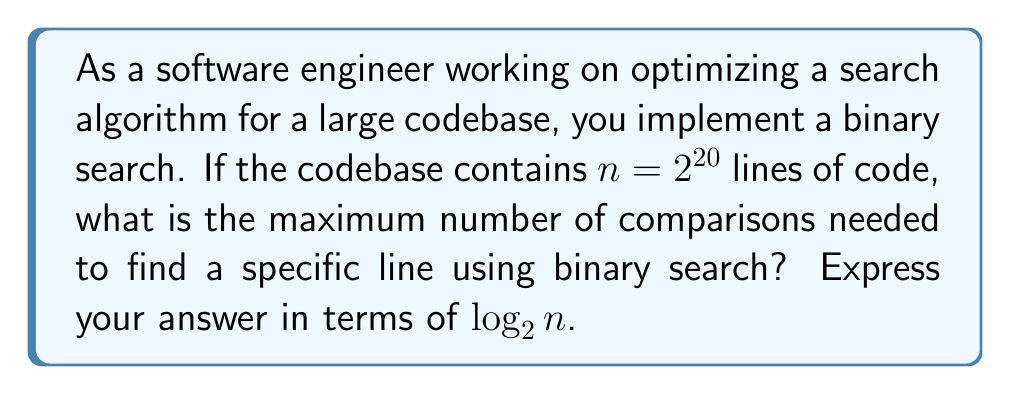Give your solution to this math problem. Let's approach this step-by-step:

1) Binary search works by repeatedly dividing the search interval in half. At each step, it compares the middle element with the target value.

2) The time complexity of binary search is $O(\log_2 n)$, where $n$ is the number of elements in the sorted array (in this case, lines of code).

3) The maximum number of comparisons occurs when the target element is at one of the ends of the array or not present at all.

4) In each step, the search space is halved:
   $n \rightarrow \frac{n}{2} \rightarrow \frac{n}{4} \rightarrow \frac{n}{8} \rightarrow ...$

5) The search terminates when the search space is reduced to 1 element.

6) Mathematically, we're looking for the smallest $k$ such that:

   $\frac{n}{2^k} = 1$

7) Solving this equation:
   $n = 2^k$
   $\log_2 n = \log_2 2^k$
   $\log_2 n = k$

8) In this specific case, $n = 2^{20}$, so:
   $\log_2 (2^{20}) = 20$

Therefore, the maximum number of comparisons is equal to $\log_2 n$, which is 20 in this case.
Answer: $\log_2 n$ 